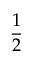<formula> <loc_0><loc_0><loc_500><loc_500>\frac { 1 } { 2 }</formula> 